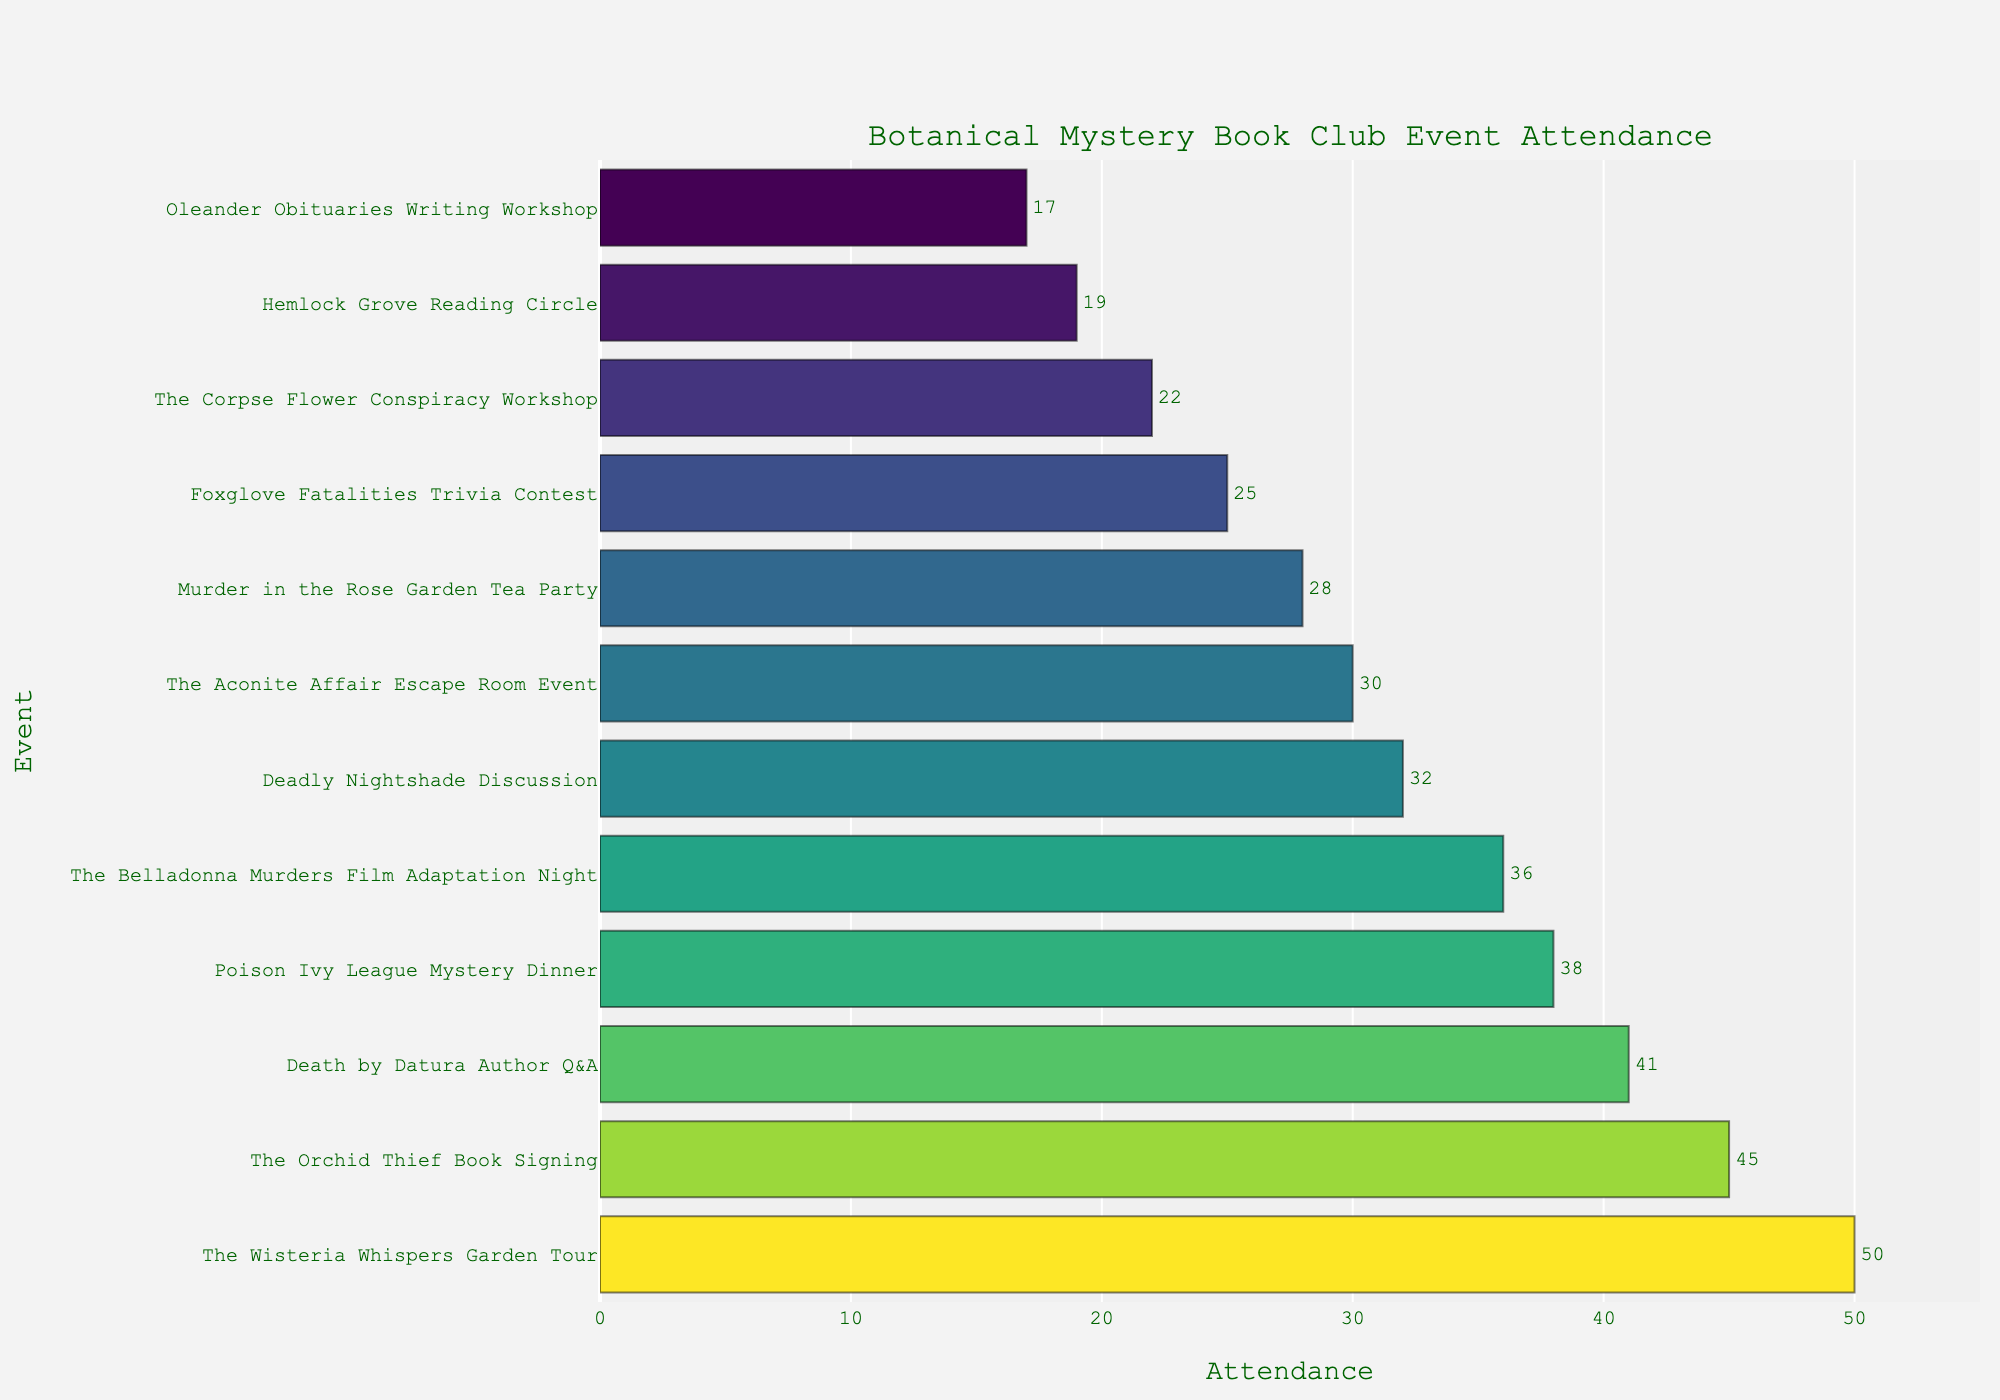What's the event with the highest attendance? To find the event with the highest attendance, look at the length of the bars. The longest bar represents the event with the most attendees.
Answer: "The Wisteria Whispers" Garden Tour Which event has the lowest attendance? To identify the event with the lowest attendance, look for the shortest bar in the plot. The shortest bar corresponds to the event with the least number of attendees.
Answer: "Oleander Obituaries" Writing Workshop What is the total attendance for all events combined? Add the attendance numbers for all the events together: 32 + 45 + 28 + 38 + 22 + 41 + 19 + 36 + 25 + 50 + 17 + 30 = 383
Answer: 383 How does the attendance of "Death by Datura" Author Q&A compare to "The Belladonna Murders" Film Adaptation Night? Note the lengths of the bars for both events. The bar for "Death by Datura" is longer than the bar for "The Belladonna Murders", indicating higher attendance. Specifically, 41 for "Death by Datura" and 36 for "The Belladonna Murders".
Answer: "Death by Datura" has higher attendance What is the average attendance across all events? Calculate the average by dividing the total attendance by the number of events. The total attendance is 383, and there are 12 events. So, 383 / 12 ≈ 31.92
Answer: 31.92 How many events have an attendance higher than 30? Identify the bars that correspond to an attendance number greater than 30. These events are "Deadly Nightshade" Discussion, "The Orchid Thief" Book Signing, "Poison Ivy League" Mystery Dinner, "Death by Datura" Author Q&A, "The Belladonna Murders" Film Adaptation Night, and "The Wisteria Whispers" Garden Tour. That's 6 events.
Answer: 6 What is the difference in attendance between the "Foxglove Fatalities" Trivia Contest and the "Hemlock Grove" Reading Circle? Subtract the attendance number of "Hemlock Grove" Reading Circle from that of the "Foxglove Fatalities" Trivia Contest. So, 25 - 19 = 6
Answer: 6 Which event has a darker shade on the color scale, "The Belladonna Murders" Film Adaptation Night or "The Aconite Affair" Escape Room Event? The color scale intensity is proportional to the attendance. Comparing the two, "The Belladonna Murders" has more attendance (36) than "The Aconite Affair" (30), meaning "The Belladonna Murders" will have a darker shade.
Answer: "The Belladonna Murders" Film Adaptation Night What's the median attendance of the events? To find the median, list the attendance numbers in ascending order and find the middle value(s). The sorted attendances are 17, 19, 22, 25, 28, 30, 32, 36, 38, 41, 45, 50. The median value falls between the 6th and 7th values, (30 + 32)/2 = 31.
Answer: 31 